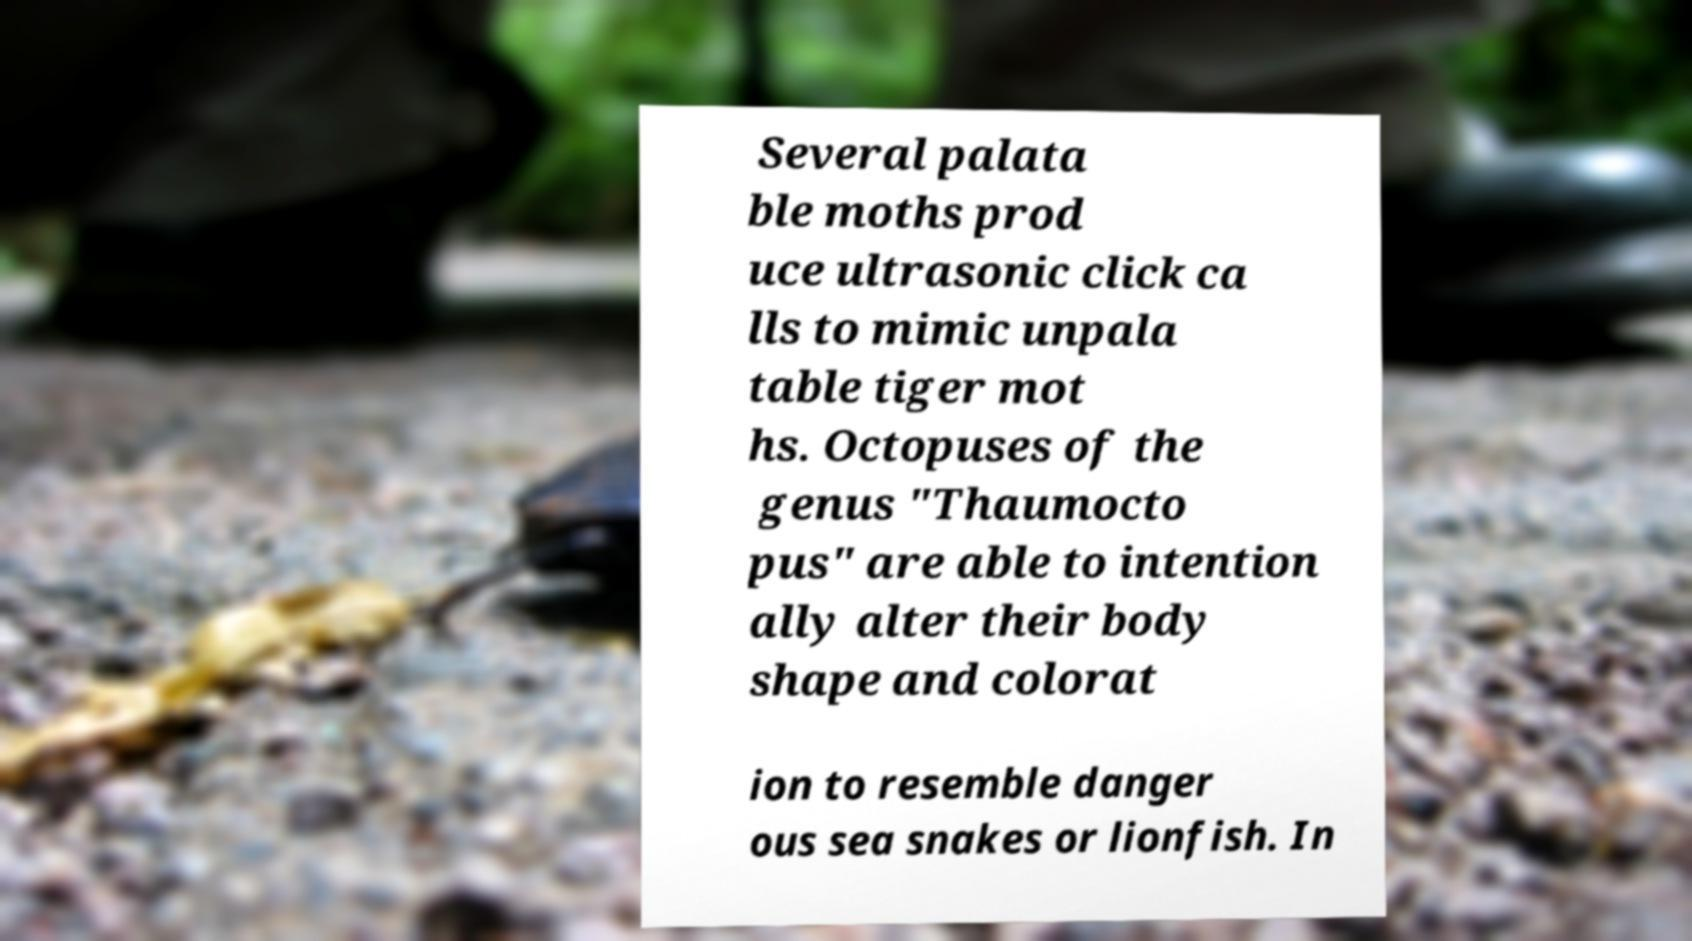Can you accurately transcribe the text from the provided image for me? Several palata ble moths prod uce ultrasonic click ca lls to mimic unpala table tiger mot hs. Octopuses of the genus "Thaumocto pus" are able to intention ally alter their body shape and colorat ion to resemble danger ous sea snakes or lionfish. In 